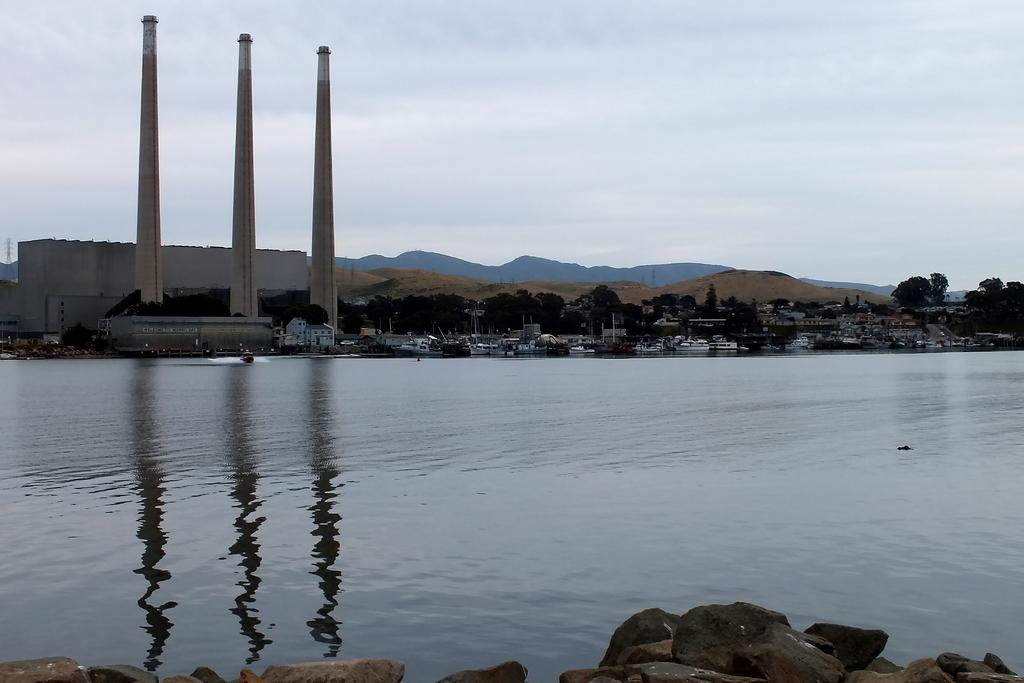What is located at the front of the image? There is water in the front of the image. What can be seen in the background of the image? There are buildings, trees, clouds, and the sky visible in the background of the image. Can you describe the natural elements in the background of the image? There are trees and clouds in the background of the image. What is the color of the sky in the image? The sky is visible in the background of the image, but the color is not specified in the provided facts. What type of vest is being worn by the tree in the image? There is no vest present in the image, as it features water, buildings, trees, clouds, and the sky. Can you recite the verse that is written on the clouds in the image? There is no verse written on the clouds in the image; they are simply visible in the background. 